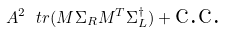Convert formula to latex. <formula><loc_0><loc_0><loc_500><loc_500>A ^ { 2 } \ t r ( M \Sigma _ { R } M ^ { T } \Sigma _ { L } ^ { \dagger } ) + \text {c.c.}</formula> 